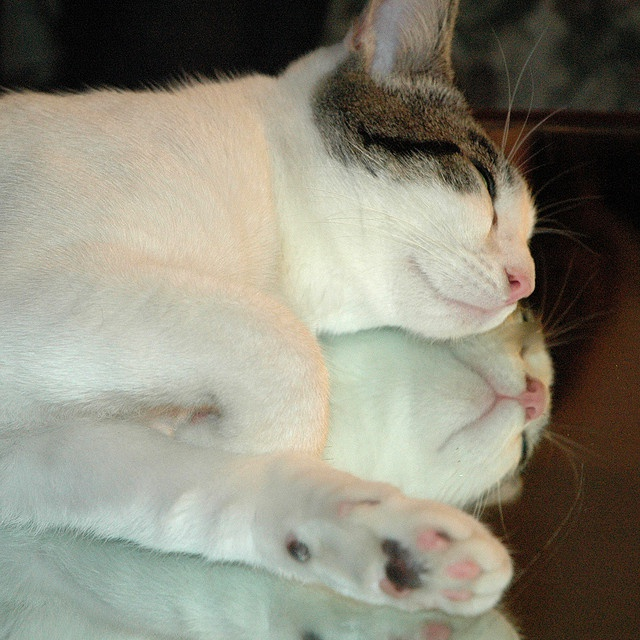Describe the objects in this image and their specific colors. I can see cat in black, darkgray, lightgray, beige, and tan tones and cat in black, darkgray, beige, and lightgray tones in this image. 